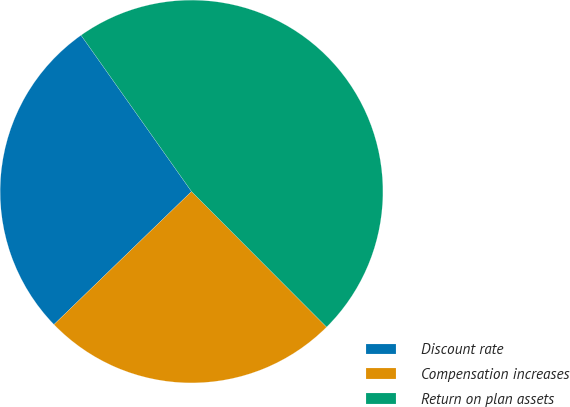<chart> <loc_0><loc_0><loc_500><loc_500><pie_chart><fcel>Discount rate<fcel>Compensation increases<fcel>Return on plan assets<nl><fcel>27.44%<fcel>25.24%<fcel>47.32%<nl></chart> 